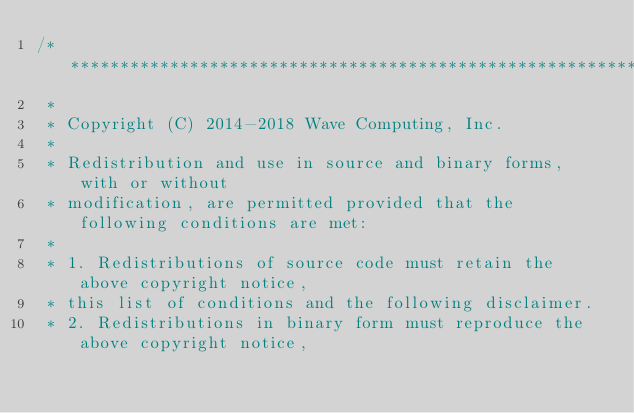<code> <loc_0><loc_0><loc_500><loc_500><_C_>/*******************************************************************************
 *
 * Copyright (C) 2014-2018 Wave Computing, Inc.
 *
 * Redistribution and use in source and binary forms, with or without
 * modification, are permitted provided that the following conditions are met:
 *
 * 1. Redistributions of source code must retain the above copyright notice,
 * this list of conditions and the following disclaimer.
 * 2. Redistributions in binary form must reproduce the above copyright notice,</code> 